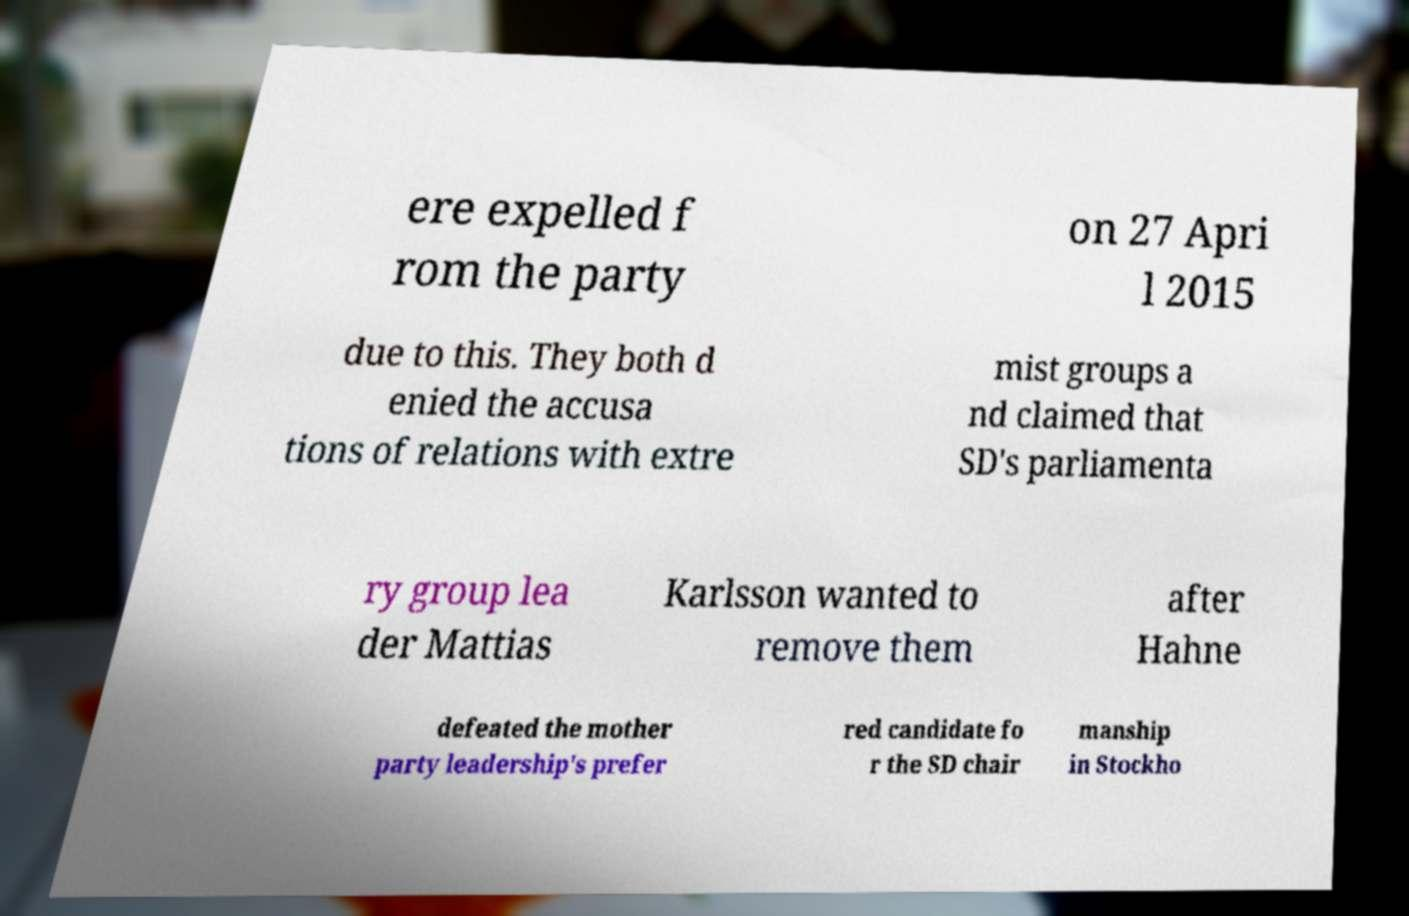I need the written content from this picture converted into text. Can you do that? ere expelled f rom the party on 27 Apri l 2015 due to this. They both d enied the accusa tions of relations with extre mist groups a nd claimed that SD's parliamenta ry group lea der Mattias Karlsson wanted to remove them after Hahne defeated the mother party leadership's prefer red candidate fo r the SD chair manship in Stockho 